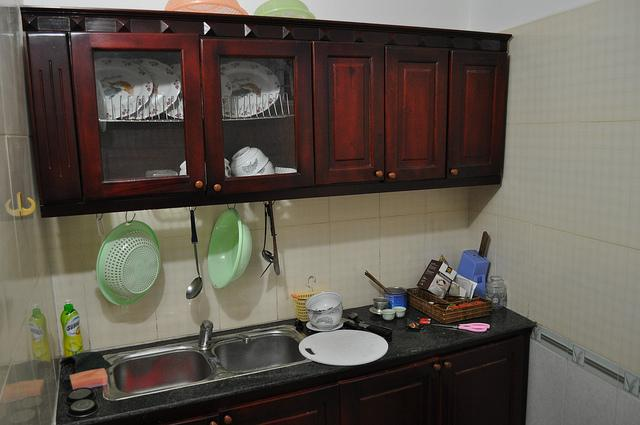What color are the noodle strainers hanging underneath of the cupboard and above the sink?

Choices:
A) two
B) three
C) five
D) four two 